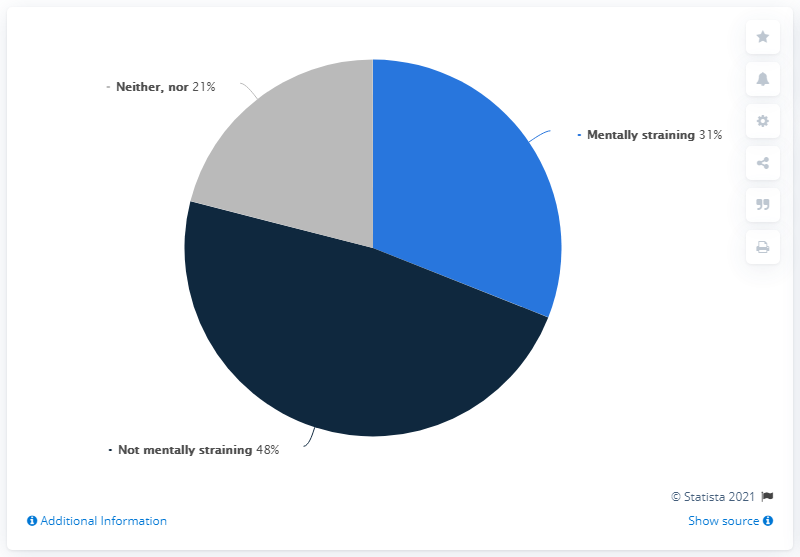Highlight a few significant elements in this photo. Out of the 48 people surveyed, 48 did not report mentally straining. The difference between the two values is 10. 